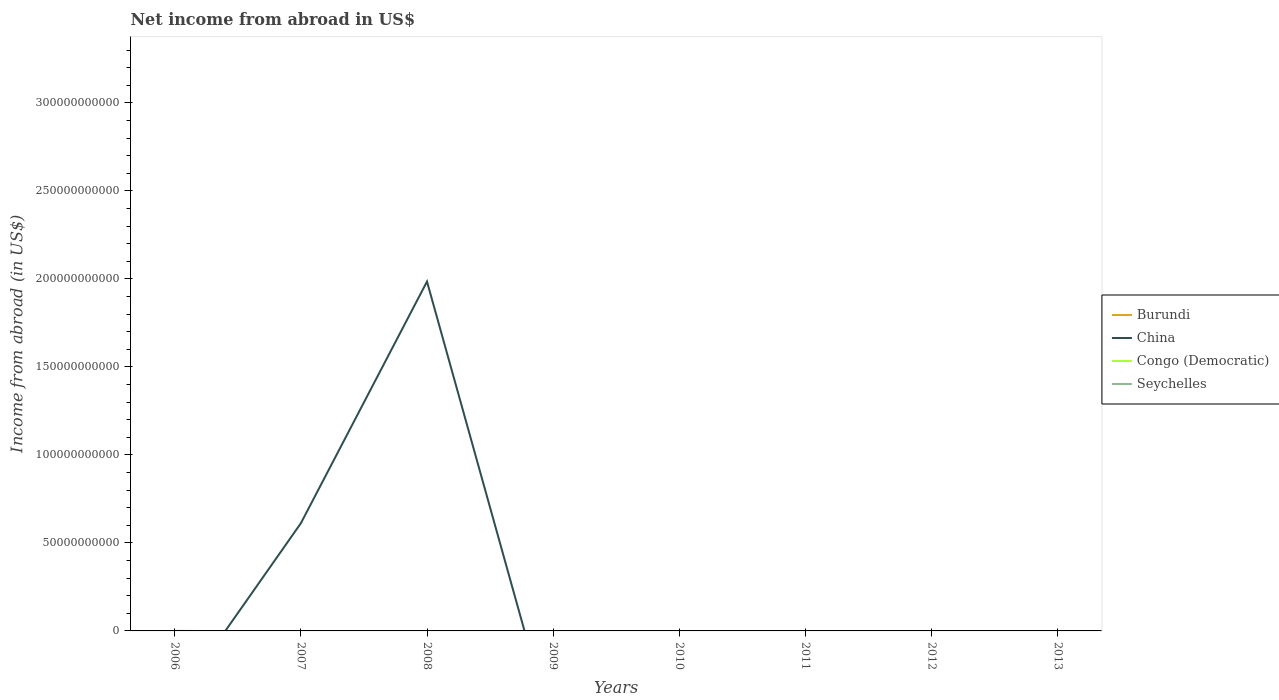How many different coloured lines are there?
Keep it short and to the point. 2. What is the difference between the highest and the second highest net income from abroad in China?
Offer a terse response. 1.98e+11. Is the net income from abroad in Seychelles strictly greater than the net income from abroad in Congo (Democratic) over the years?
Provide a succinct answer. No. How many lines are there?
Your answer should be compact. 2. How many years are there in the graph?
Give a very brief answer. 8. What is the difference between two consecutive major ticks on the Y-axis?
Offer a very short reply. 5.00e+1. Are the values on the major ticks of Y-axis written in scientific E-notation?
Your answer should be compact. No. How are the legend labels stacked?
Keep it short and to the point. Vertical. What is the title of the graph?
Your answer should be very brief. Net income from abroad in US$. Does "Seychelles" appear as one of the legend labels in the graph?
Keep it short and to the point. Yes. What is the label or title of the X-axis?
Your response must be concise. Years. What is the label or title of the Y-axis?
Keep it short and to the point. Income from abroad (in US$). What is the Income from abroad (in US$) in China in 2006?
Ensure brevity in your answer.  0. What is the Income from abroad (in US$) in Congo (Democratic) in 2006?
Your response must be concise. 0. What is the Income from abroad (in US$) of Seychelles in 2006?
Your answer should be compact. 5.71e+07. What is the Income from abroad (in US$) of China in 2007?
Offer a terse response. 6.12e+1. What is the Income from abroad (in US$) of Congo (Democratic) in 2007?
Offer a terse response. 0. What is the Income from abroad (in US$) in Seychelles in 2007?
Give a very brief answer. 0. What is the Income from abroad (in US$) in China in 2008?
Provide a succinct answer. 1.98e+11. What is the Income from abroad (in US$) in Congo (Democratic) in 2008?
Ensure brevity in your answer.  0. What is the Income from abroad (in US$) of Burundi in 2009?
Your answer should be very brief. 0. What is the Income from abroad (in US$) in China in 2009?
Your answer should be compact. 0. What is the Income from abroad (in US$) of Congo (Democratic) in 2009?
Offer a very short reply. 0. What is the Income from abroad (in US$) of China in 2010?
Provide a short and direct response. 0. What is the Income from abroad (in US$) of Congo (Democratic) in 2010?
Give a very brief answer. 0. What is the Income from abroad (in US$) in Seychelles in 2012?
Give a very brief answer. 0. What is the Income from abroad (in US$) in Congo (Democratic) in 2013?
Provide a short and direct response. 0. Across all years, what is the maximum Income from abroad (in US$) of China?
Provide a succinct answer. 1.98e+11. Across all years, what is the maximum Income from abroad (in US$) in Seychelles?
Provide a succinct answer. 5.71e+07. Across all years, what is the minimum Income from abroad (in US$) of China?
Your answer should be very brief. 0. Across all years, what is the minimum Income from abroad (in US$) in Seychelles?
Give a very brief answer. 0. What is the total Income from abroad (in US$) in Burundi in the graph?
Provide a succinct answer. 0. What is the total Income from abroad (in US$) of China in the graph?
Provide a succinct answer. 2.60e+11. What is the total Income from abroad (in US$) in Seychelles in the graph?
Your answer should be very brief. 5.71e+07. What is the difference between the Income from abroad (in US$) in China in 2007 and that in 2008?
Make the answer very short. -1.37e+11. What is the average Income from abroad (in US$) of Burundi per year?
Offer a terse response. 0. What is the average Income from abroad (in US$) in China per year?
Keep it short and to the point. 3.25e+1. What is the average Income from abroad (in US$) of Seychelles per year?
Provide a succinct answer. 7.14e+06. What is the ratio of the Income from abroad (in US$) in China in 2007 to that in 2008?
Your answer should be compact. 0.31. What is the difference between the highest and the lowest Income from abroad (in US$) in China?
Offer a very short reply. 1.98e+11. What is the difference between the highest and the lowest Income from abroad (in US$) of Seychelles?
Ensure brevity in your answer.  5.71e+07. 